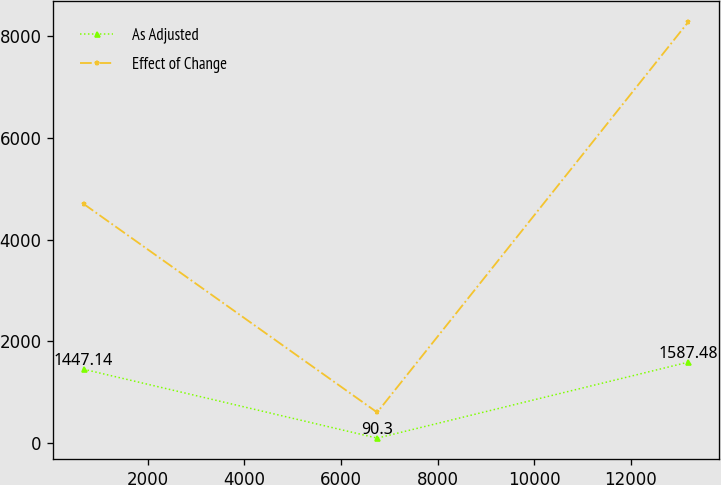<chart> <loc_0><loc_0><loc_500><loc_500><line_chart><ecel><fcel>As Adjusted<fcel>Effect of Change<nl><fcel>677.02<fcel>1447.14<fcel>4702.56<nl><fcel>6751.09<fcel>90.3<fcel>597.36<nl><fcel>13193.9<fcel>1587.48<fcel>8290.69<nl></chart> 